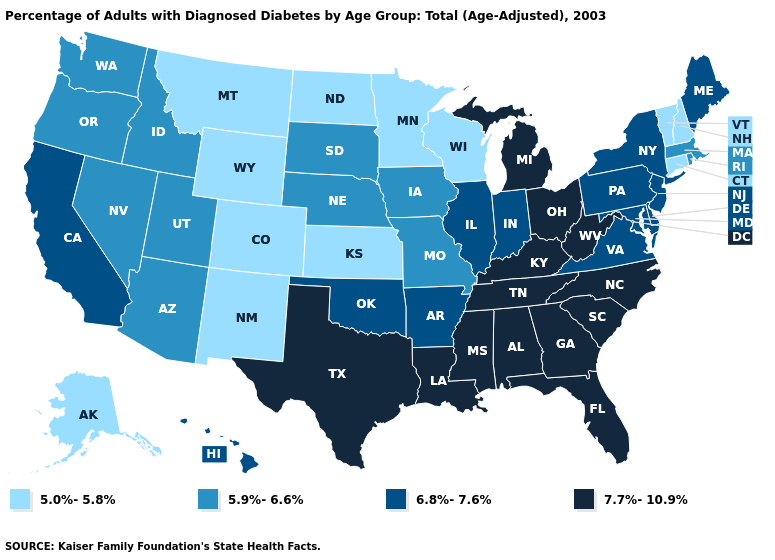What is the value of Wyoming?
Answer briefly. 5.0%-5.8%. Name the states that have a value in the range 5.0%-5.8%?
Give a very brief answer. Alaska, Colorado, Connecticut, Kansas, Minnesota, Montana, New Hampshire, New Mexico, North Dakota, Vermont, Wisconsin, Wyoming. What is the lowest value in states that border Texas?
Concise answer only. 5.0%-5.8%. What is the highest value in the MidWest ?
Answer briefly. 7.7%-10.9%. Among the states that border Maine , which have the lowest value?
Give a very brief answer. New Hampshire. What is the value of Iowa?
Give a very brief answer. 5.9%-6.6%. Which states have the lowest value in the MidWest?
Answer briefly. Kansas, Minnesota, North Dakota, Wisconsin. Is the legend a continuous bar?
Answer briefly. No. What is the value of New Mexico?
Be succinct. 5.0%-5.8%. What is the value of Maryland?
Quick response, please. 6.8%-7.6%. Name the states that have a value in the range 7.7%-10.9%?
Short answer required. Alabama, Florida, Georgia, Kentucky, Louisiana, Michigan, Mississippi, North Carolina, Ohio, South Carolina, Tennessee, Texas, West Virginia. Name the states that have a value in the range 6.8%-7.6%?
Concise answer only. Arkansas, California, Delaware, Hawaii, Illinois, Indiana, Maine, Maryland, New Jersey, New York, Oklahoma, Pennsylvania, Virginia. How many symbols are there in the legend?
Be succinct. 4. Which states have the highest value in the USA?
Keep it brief. Alabama, Florida, Georgia, Kentucky, Louisiana, Michigan, Mississippi, North Carolina, Ohio, South Carolina, Tennessee, Texas, West Virginia. Does Michigan have a higher value than Louisiana?
Quick response, please. No. 